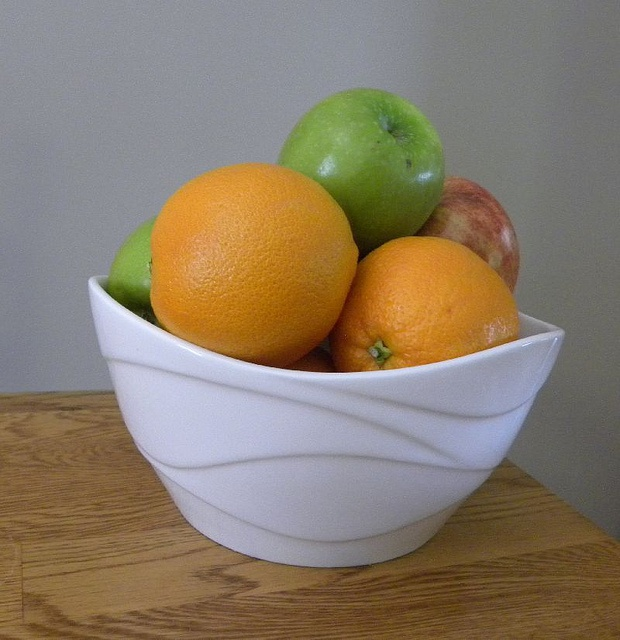Describe the objects in this image and their specific colors. I can see dining table in darkgray, maroon, gray, and olive tones, bowl in darkgray, lavender, and gray tones, orange in darkgray, olive, orange, and maroon tones, orange in darkgray, olive, orange, and maroon tones, and apple in darkgray, darkgreen, olive, and green tones in this image. 